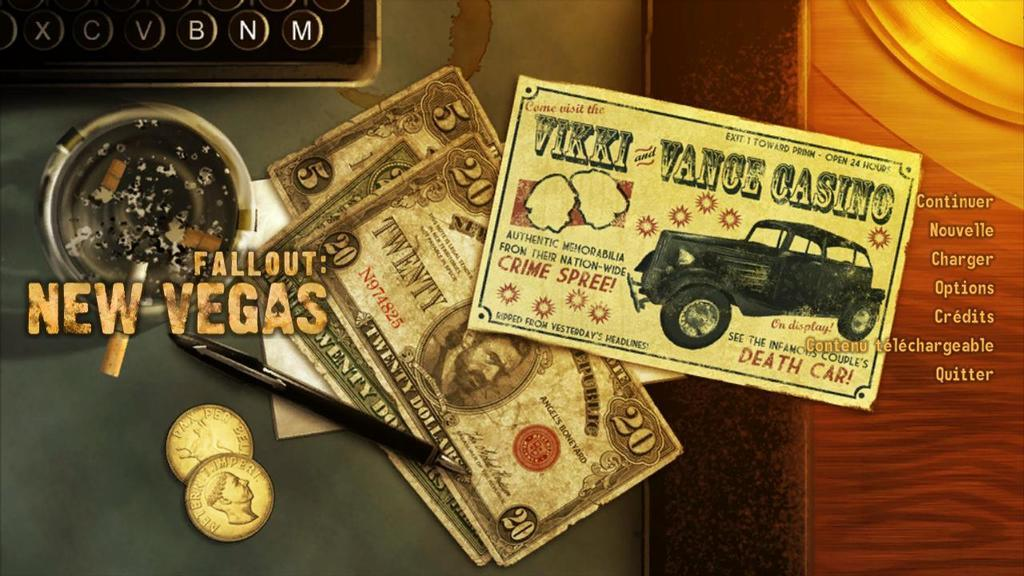<image>
Render a clear and concise summary of the photo. A card from Vikki Vance Casino is shown here. 